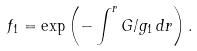<formula> <loc_0><loc_0><loc_500><loc_500>f _ { 1 } = \exp \left ( - \int ^ { r } G / g _ { 1 } \, d r \right ) .</formula> 